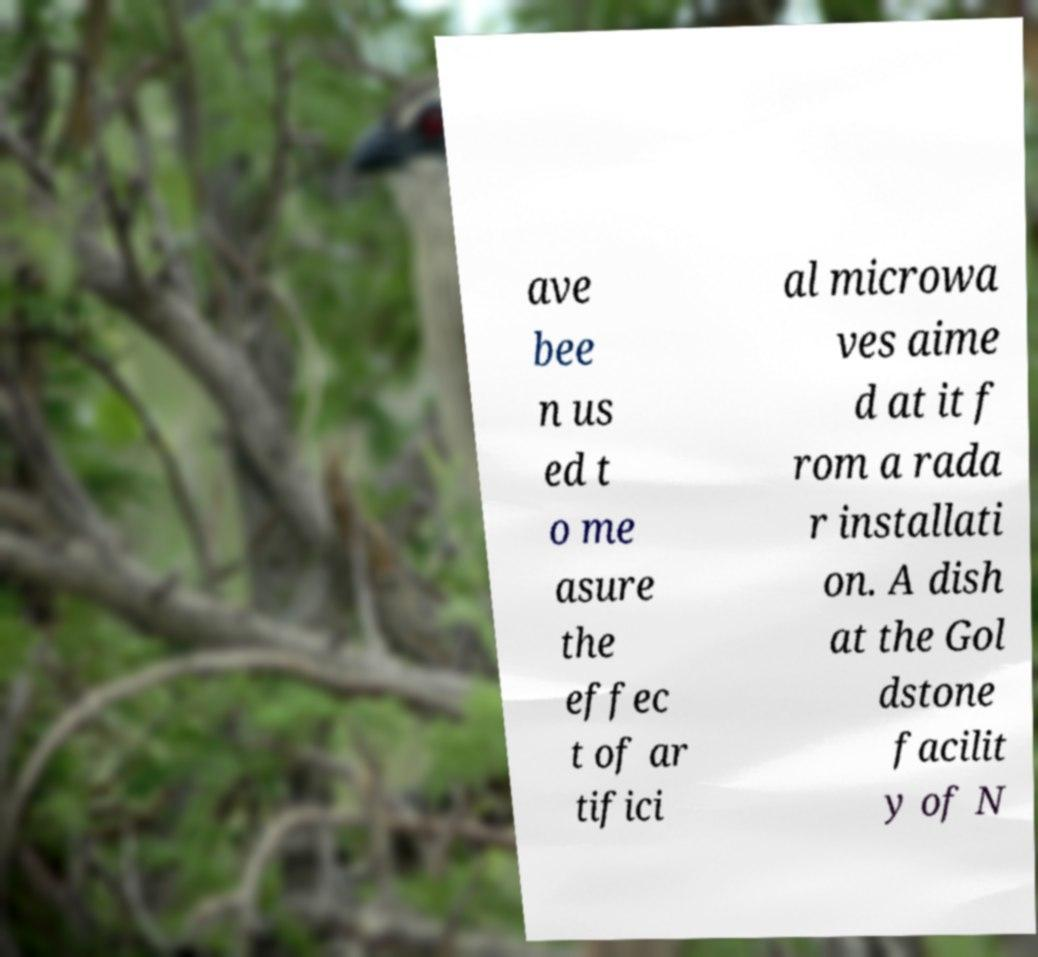Can you read and provide the text displayed in the image?This photo seems to have some interesting text. Can you extract and type it out for me? ave bee n us ed t o me asure the effec t of ar tifici al microwa ves aime d at it f rom a rada r installati on. A dish at the Gol dstone facilit y of N 